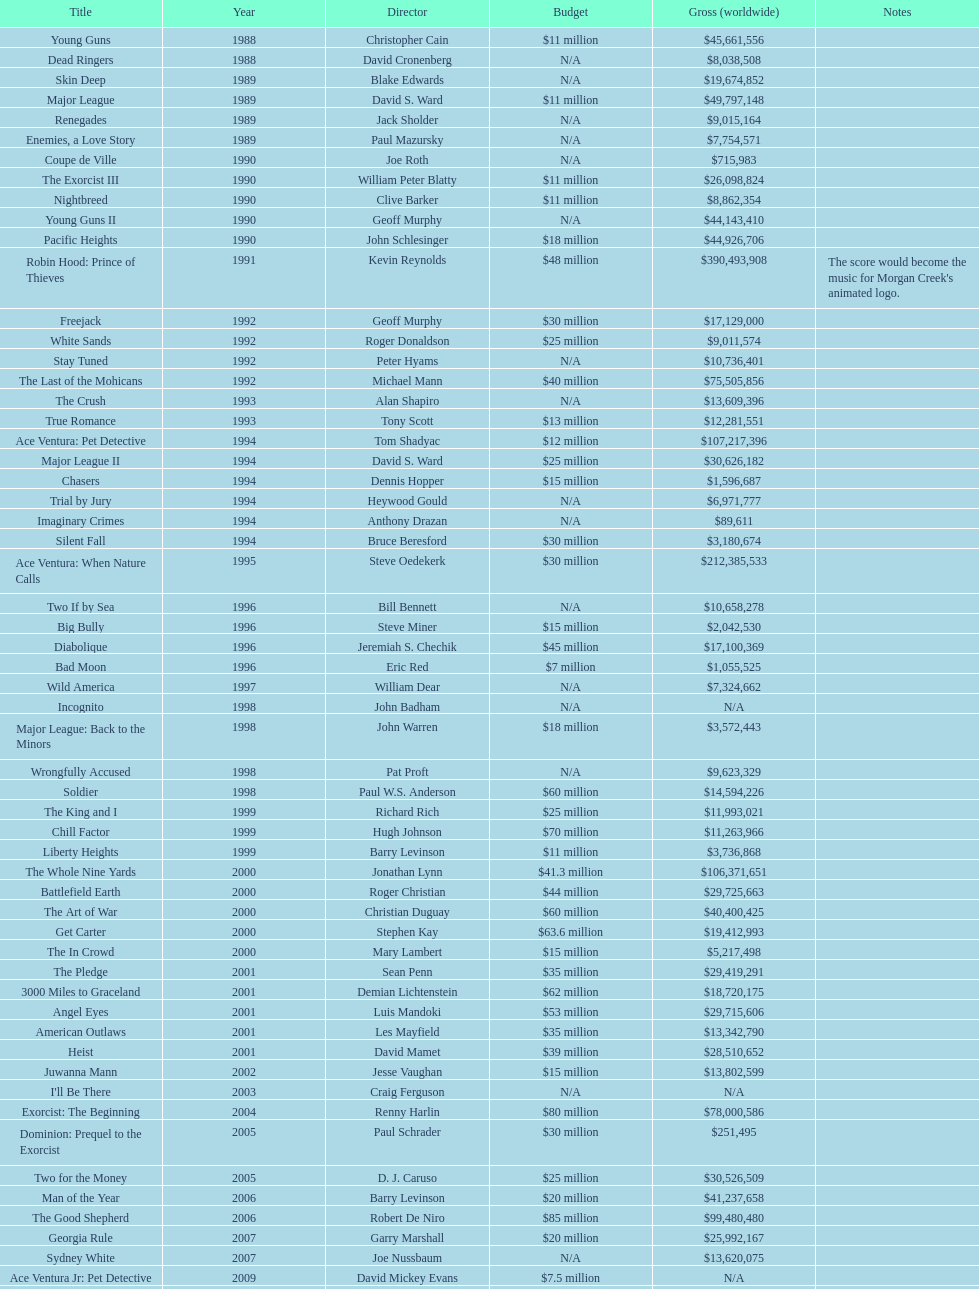What is the most profitable film? Robin Hood: Prince of Thieves. 